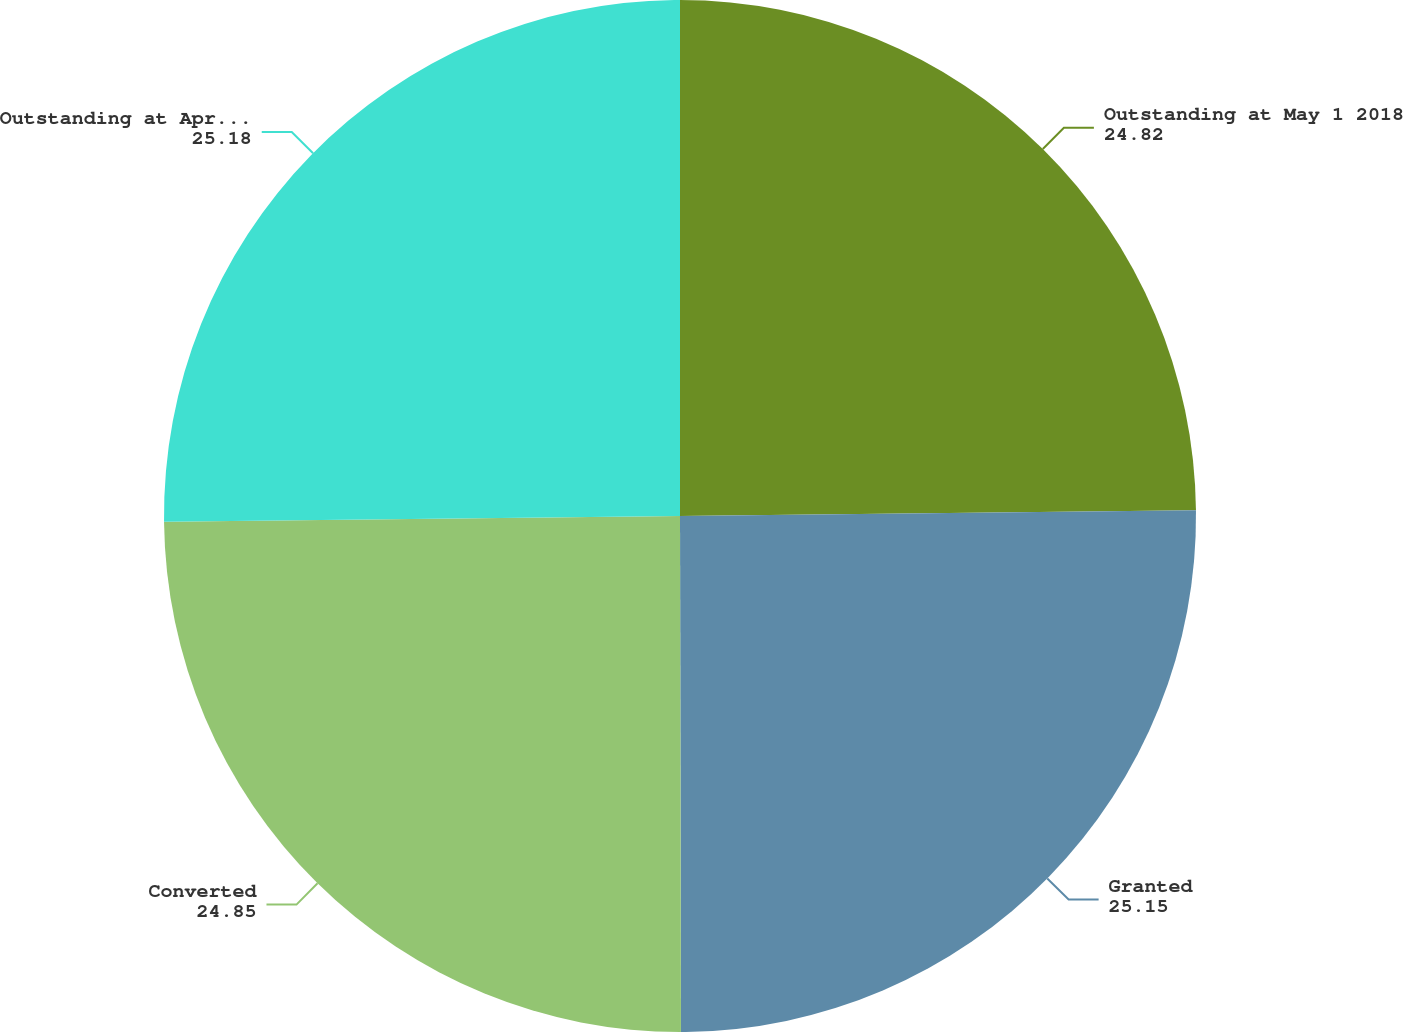Convert chart. <chart><loc_0><loc_0><loc_500><loc_500><pie_chart><fcel>Outstanding at May 1 2018<fcel>Granted<fcel>Converted<fcel>Outstanding at April 30 2019<nl><fcel>24.82%<fcel>25.15%<fcel>24.85%<fcel>25.18%<nl></chart> 